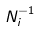<formula> <loc_0><loc_0><loc_500><loc_500>N _ { i } ^ { - 1 }</formula> 